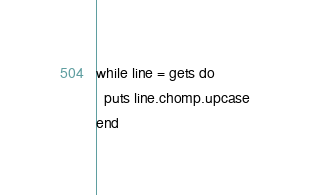<code> <loc_0><loc_0><loc_500><loc_500><_Ruby_>while line = gets do
  puts line.chomp.upcase
end</code> 